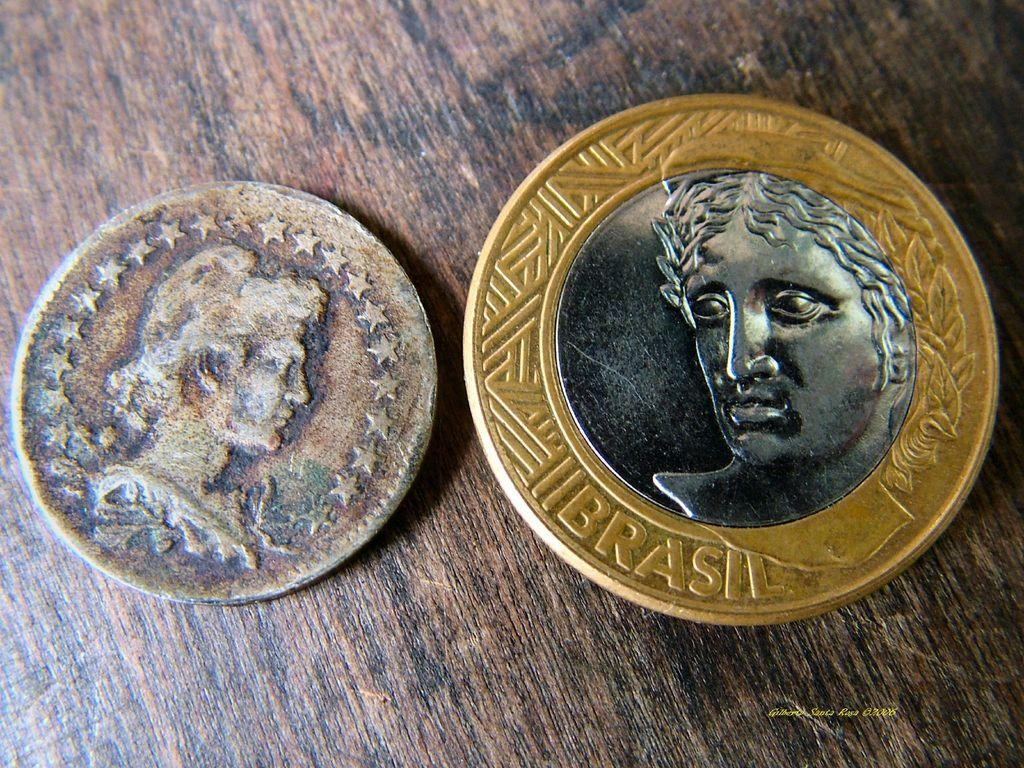<image>
Provide a brief description of the given image. Two coins sit side by side, one small and very old, another newer and labeled Brasil. 